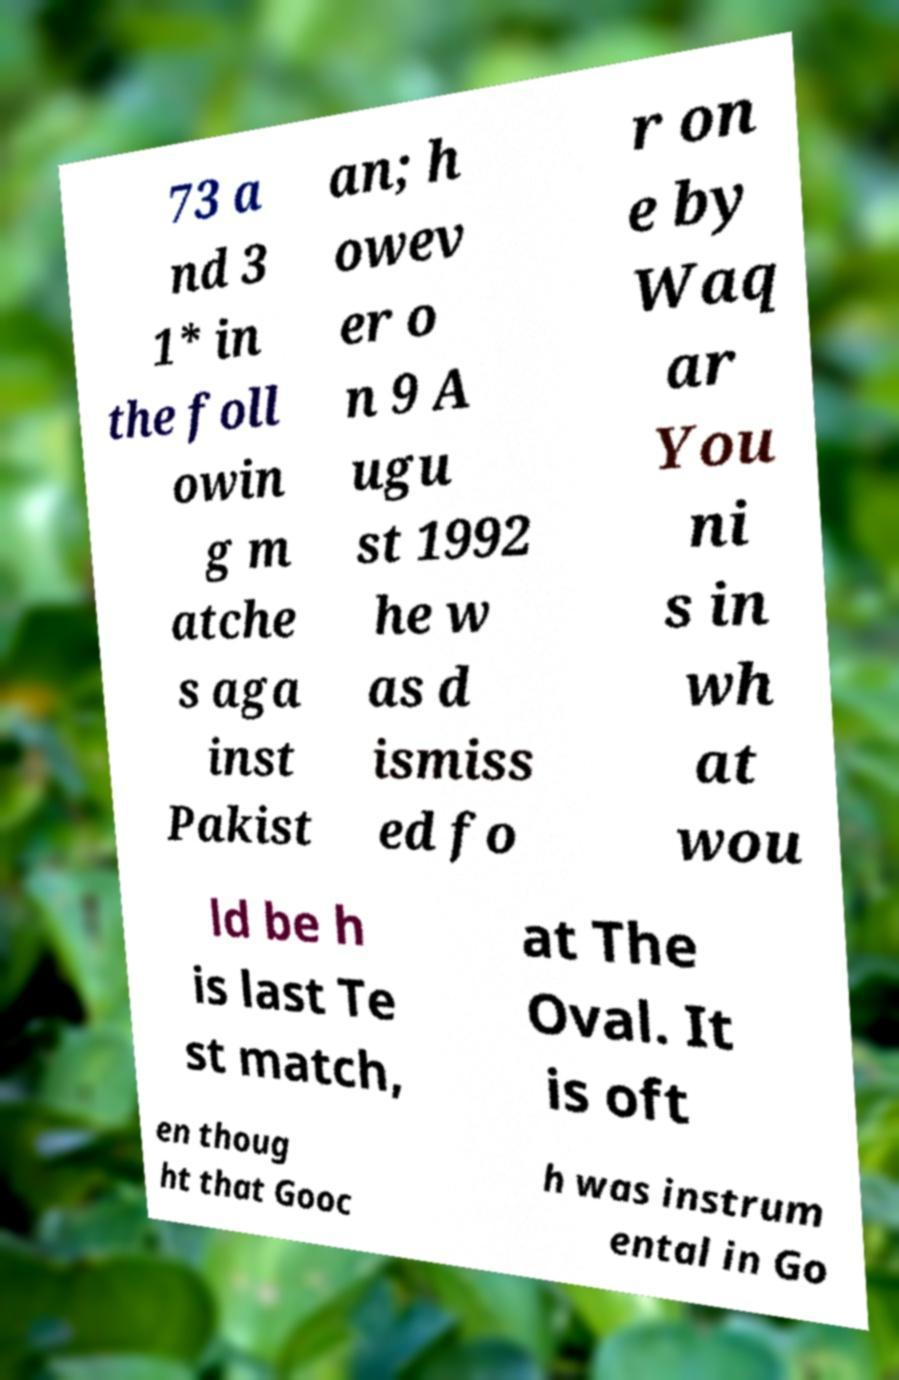Please read and relay the text visible in this image. What does it say? 73 a nd 3 1* in the foll owin g m atche s aga inst Pakist an; h owev er o n 9 A ugu st 1992 he w as d ismiss ed fo r on e by Waq ar You ni s in wh at wou ld be h is last Te st match, at The Oval. It is oft en thoug ht that Gooc h was instrum ental in Go 